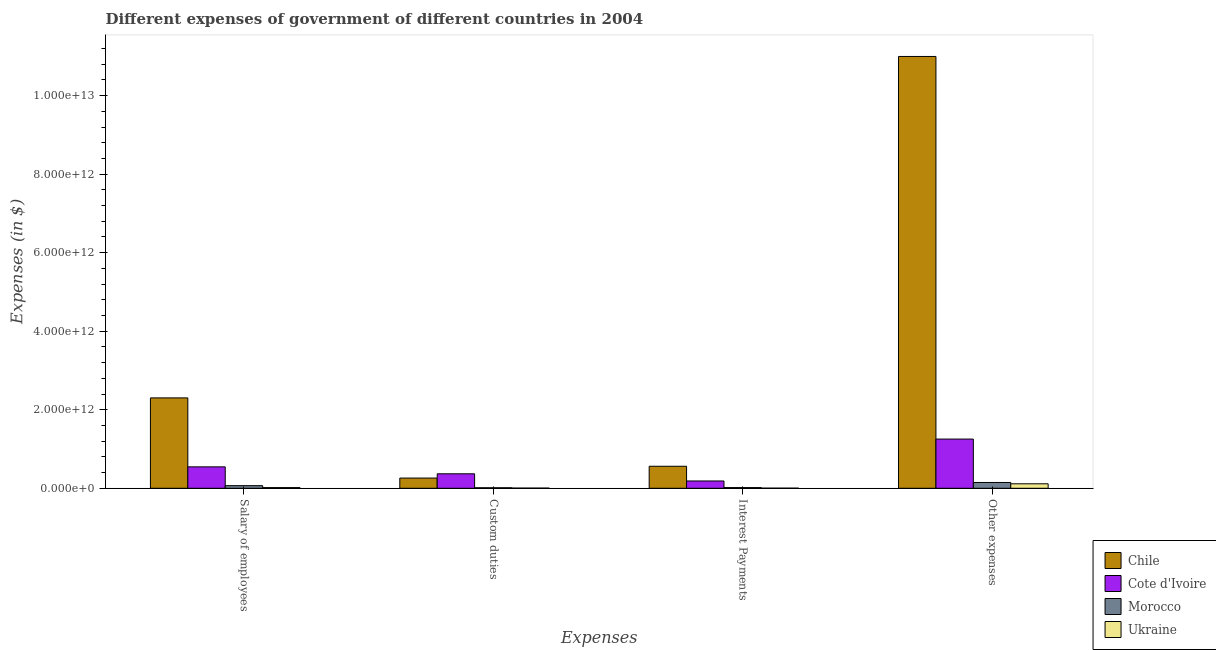How many different coloured bars are there?
Your answer should be compact. 4. Are the number of bars per tick equal to the number of legend labels?
Ensure brevity in your answer.  Yes. How many bars are there on the 2nd tick from the left?
Offer a terse response. 4. How many bars are there on the 4th tick from the right?
Your answer should be very brief. 4. What is the label of the 3rd group of bars from the left?
Provide a short and direct response. Interest Payments. What is the amount spent on interest payments in Chile?
Provide a short and direct response. 5.61e+11. Across all countries, what is the maximum amount spent on other expenses?
Give a very brief answer. 1.10e+13. Across all countries, what is the minimum amount spent on custom duties?
Your response must be concise. 4.37e+09. In which country was the amount spent on interest payments maximum?
Make the answer very short. Chile. In which country was the amount spent on salary of employees minimum?
Your answer should be very brief. Ukraine. What is the total amount spent on custom duties in the graph?
Your answer should be compact. 6.46e+11. What is the difference between the amount spent on other expenses in Chile and that in Ukraine?
Provide a succinct answer. 1.09e+13. What is the difference between the amount spent on other expenses in Chile and the amount spent on custom duties in Cote d'Ivoire?
Ensure brevity in your answer.  1.06e+13. What is the average amount spent on salary of employees per country?
Offer a terse response. 7.33e+11. What is the difference between the amount spent on salary of employees and amount spent on custom duties in Cote d'Ivoire?
Provide a short and direct response. 1.77e+11. In how many countries, is the amount spent on custom duties greater than 4000000000000 $?
Offer a very short reply. 0. What is the ratio of the amount spent on interest payments in Morocco to that in Cote d'Ivoire?
Ensure brevity in your answer.  0.1. Is the amount spent on custom duties in Ukraine less than that in Chile?
Your answer should be compact. Yes. Is the difference between the amount spent on custom duties in Ukraine and Morocco greater than the difference between the amount spent on salary of employees in Ukraine and Morocco?
Ensure brevity in your answer.  Yes. What is the difference between the highest and the second highest amount spent on custom duties?
Provide a short and direct response. 1.09e+11. What is the difference between the highest and the lowest amount spent on salary of employees?
Your answer should be compact. 2.28e+12. What does the 3rd bar from the left in Interest Payments represents?
Your answer should be very brief. Morocco. Is it the case that in every country, the sum of the amount spent on salary of employees and amount spent on custom duties is greater than the amount spent on interest payments?
Offer a terse response. Yes. Are all the bars in the graph horizontal?
Provide a short and direct response. No. How many countries are there in the graph?
Provide a short and direct response. 4. What is the difference between two consecutive major ticks on the Y-axis?
Provide a succinct answer. 2.00e+12. Are the values on the major ticks of Y-axis written in scientific E-notation?
Offer a terse response. Yes. Does the graph contain any zero values?
Make the answer very short. No. Does the graph contain grids?
Offer a very short reply. No. Where does the legend appear in the graph?
Keep it short and to the point. Bottom right. What is the title of the graph?
Your answer should be very brief. Different expenses of government of different countries in 2004. What is the label or title of the X-axis?
Ensure brevity in your answer.  Expenses. What is the label or title of the Y-axis?
Your response must be concise. Expenses (in $). What is the Expenses (in $) in Chile in Salary of employees?
Make the answer very short. 2.30e+12. What is the Expenses (in $) of Cote d'Ivoire in Salary of employees?
Provide a short and direct response. 5.46e+11. What is the Expenses (in $) in Morocco in Salary of employees?
Your answer should be compact. 6.65e+1. What is the Expenses (in $) in Ukraine in Salary of employees?
Provide a succinct answer. 1.79e+1. What is the Expenses (in $) in Chile in Custom duties?
Offer a terse response. 2.60e+11. What is the Expenses (in $) in Cote d'Ivoire in Custom duties?
Your response must be concise. 3.69e+11. What is the Expenses (in $) of Morocco in Custom duties?
Your response must be concise. 1.33e+1. What is the Expenses (in $) of Ukraine in Custom duties?
Your answer should be compact. 4.37e+09. What is the Expenses (in $) in Chile in Interest Payments?
Make the answer very short. 5.61e+11. What is the Expenses (in $) in Cote d'Ivoire in Interest Payments?
Provide a short and direct response. 1.86e+11. What is the Expenses (in $) of Morocco in Interest Payments?
Make the answer very short. 1.77e+1. What is the Expenses (in $) in Ukraine in Interest Payments?
Ensure brevity in your answer.  3.05e+09. What is the Expenses (in $) of Chile in Other expenses?
Your response must be concise. 1.10e+13. What is the Expenses (in $) in Cote d'Ivoire in Other expenses?
Offer a very short reply. 1.25e+12. What is the Expenses (in $) of Morocco in Other expenses?
Offer a very short reply. 1.48e+11. What is the Expenses (in $) in Ukraine in Other expenses?
Provide a succinct answer. 1.14e+11. Across all Expenses, what is the maximum Expenses (in $) in Chile?
Ensure brevity in your answer.  1.10e+13. Across all Expenses, what is the maximum Expenses (in $) in Cote d'Ivoire?
Your answer should be compact. 1.25e+12. Across all Expenses, what is the maximum Expenses (in $) of Morocco?
Provide a succinct answer. 1.48e+11. Across all Expenses, what is the maximum Expenses (in $) of Ukraine?
Keep it short and to the point. 1.14e+11. Across all Expenses, what is the minimum Expenses (in $) of Chile?
Keep it short and to the point. 2.60e+11. Across all Expenses, what is the minimum Expenses (in $) of Cote d'Ivoire?
Make the answer very short. 1.86e+11. Across all Expenses, what is the minimum Expenses (in $) of Morocco?
Provide a succinct answer. 1.33e+1. Across all Expenses, what is the minimum Expenses (in $) of Ukraine?
Ensure brevity in your answer.  3.05e+09. What is the total Expenses (in $) in Chile in the graph?
Provide a short and direct response. 1.41e+13. What is the total Expenses (in $) in Cote d'Ivoire in the graph?
Provide a short and direct response. 2.35e+12. What is the total Expenses (in $) in Morocco in the graph?
Provide a short and direct response. 2.45e+11. What is the total Expenses (in $) in Ukraine in the graph?
Provide a succinct answer. 1.39e+11. What is the difference between the Expenses (in $) of Chile in Salary of employees and that in Custom duties?
Keep it short and to the point. 2.04e+12. What is the difference between the Expenses (in $) in Cote d'Ivoire in Salary of employees and that in Custom duties?
Your answer should be very brief. 1.77e+11. What is the difference between the Expenses (in $) in Morocco in Salary of employees and that in Custom duties?
Your answer should be compact. 5.32e+1. What is the difference between the Expenses (in $) of Ukraine in Salary of employees and that in Custom duties?
Give a very brief answer. 1.35e+1. What is the difference between the Expenses (in $) of Chile in Salary of employees and that in Interest Payments?
Offer a very short reply. 1.74e+12. What is the difference between the Expenses (in $) of Cote d'Ivoire in Salary of employees and that in Interest Payments?
Offer a very short reply. 3.60e+11. What is the difference between the Expenses (in $) of Morocco in Salary of employees and that in Interest Payments?
Your answer should be very brief. 4.88e+1. What is the difference between the Expenses (in $) of Ukraine in Salary of employees and that in Interest Payments?
Your answer should be very brief. 1.48e+1. What is the difference between the Expenses (in $) of Chile in Salary of employees and that in Other expenses?
Offer a very short reply. -8.69e+12. What is the difference between the Expenses (in $) in Cote d'Ivoire in Salary of employees and that in Other expenses?
Make the answer very short. -7.07e+11. What is the difference between the Expenses (in $) in Morocco in Salary of employees and that in Other expenses?
Provide a short and direct response. -8.11e+1. What is the difference between the Expenses (in $) in Ukraine in Salary of employees and that in Other expenses?
Provide a succinct answer. -9.60e+1. What is the difference between the Expenses (in $) of Chile in Custom duties and that in Interest Payments?
Provide a succinct answer. -3.01e+11. What is the difference between the Expenses (in $) of Cote d'Ivoire in Custom duties and that in Interest Payments?
Make the answer very short. 1.83e+11. What is the difference between the Expenses (in $) of Morocco in Custom duties and that in Interest Payments?
Give a very brief answer. -4.45e+09. What is the difference between the Expenses (in $) of Ukraine in Custom duties and that in Interest Payments?
Your answer should be very brief. 1.32e+09. What is the difference between the Expenses (in $) of Chile in Custom duties and that in Other expenses?
Provide a succinct answer. -1.07e+13. What is the difference between the Expenses (in $) in Cote d'Ivoire in Custom duties and that in Other expenses?
Make the answer very short. -8.84e+11. What is the difference between the Expenses (in $) of Morocco in Custom duties and that in Other expenses?
Make the answer very short. -1.34e+11. What is the difference between the Expenses (in $) of Ukraine in Custom duties and that in Other expenses?
Offer a terse response. -1.09e+11. What is the difference between the Expenses (in $) in Chile in Interest Payments and that in Other expenses?
Keep it short and to the point. -1.04e+13. What is the difference between the Expenses (in $) in Cote d'Ivoire in Interest Payments and that in Other expenses?
Provide a succinct answer. -1.07e+12. What is the difference between the Expenses (in $) of Morocco in Interest Payments and that in Other expenses?
Ensure brevity in your answer.  -1.30e+11. What is the difference between the Expenses (in $) of Ukraine in Interest Payments and that in Other expenses?
Ensure brevity in your answer.  -1.11e+11. What is the difference between the Expenses (in $) of Chile in Salary of employees and the Expenses (in $) of Cote d'Ivoire in Custom duties?
Ensure brevity in your answer.  1.93e+12. What is the difference between the Expenses (in $) of Chile in Salary of employees and the Expenses (in $) of Morocco in Custom duties?
Ensure brevity in your answer.  2.29e+12. What is the difference between the Expenses (in $) of Chile in Salary of employees and the Expenses (in $) of Ukraine in Custom duties?
Keep it short and to the point. 2.30e+12. What is the difference between the Expenses (in $) of Cote d'Ivoire in Salary of employees and the Expenses (in $) of Morocco in Custom duties?
Keep it short and to the point. 5.33e+11. What is the difference between the Expenses (in $) in Cote d'Ivoire in Salary of employees and the Expenses (in $) in Ukraine in Custom duties?
Your answer should be very brief. 5.41e+11. What is the difference between the Expenses (in $) of Morocco in Salary of employees and the Expenses (in $) of Ukraine in Custom duties?
Give a very brief answer. 6.22e+1. What is the difference between the Expenses (in $) in Chile in Salary of employees and the Expenses (in $) in Cote d'Ivoire in Interest Payments?
Provide a succinct answer. 2.12e+12. What is the difference between the Expenses (in $) in Chile in Salary of employees and the Expenses (in $) in Morocco in Interest Payments?
Give a very brief answer. 2.28e+12. What is the difference between the Expenses (in $) of Chile in Salary of employees and the Expenses (in $) of Ukraine in Interest Payments?
Offer a very short reply. 2.30e+12. What is the difference between the Expenses (in $) in Cote d'Ivoire in Salary of employees and the Expenses (in $) in Morocco in Interest Payments?
Ensure brevity in your answer.  5.28e+11. What is the difference between the Expenses (in $) in Cote d'Ivoire in Salary of employees and the Expenses (in $) in Ukraine in Interest Payments?
Make the answer very short. 5.43e+11. What is the difference between the Expenses (in $) of Morocco in Salary of employees and the Expenses (in $) of Ukraine in Interest Payments?
Your answer should be very brief. 6.35e+1. What is the difference between the Expenses (in $) in Chile in Salary of employees and the Expenses (in $) in Cote d'Ivoire in Other expenses?
Make the answer very short. 1.05e+12. What is the difference between the Expenses (in $) in Chile in Salary of employees and the Expenses (in $) in Morocco in Other expenses?
Offer a very short reply. 2.15e+12. What is the difference between the Expenses (in $) of Chile in Salary of employees and the Expenses (in $) of Ukraine in Other expenses?
Your answer should be very brief. 2.19e+12. What is the difference between the Expenses (in $) in Cote d'Ivoire in Salary of employees and the Expenses (in $) in Morocco in Other expenses?
Ensure brevity in your answer.  3.98e+11. What is the difference between the Expenses (in $) of Cote d'Ivoire in Salary of employees and the Expenses (in $) of Ukraine in Other expenses?
Your answer should be very brief. 4.32e+11. What is the difference between the Expenses (in $) in Morocco in Salary of employees and the Expenses (in $) in Ukraine in Other expenses?
Provide a short and direct response. -4.73e+1. What is the difference between the Expenses (in $) of Chile in Custom duties and the Expenses (in $) of Cote d'Ivoire in Interest Payments?
Ensure brevity in your answer.  7.38e+1. What is the difference between the Expenses (in $) in Chile in Custom duties and the Expenses (in $) in Morocco in Interest Payments?
Provide a succinct answer. 2.42e+11. What is the difference between the Expenses (in $) in Chile in Custom duties and the Expenses (in $) in Ukraine in Interest Payments?
Provide a succinct answer. 2.57e+11. What is the difference between the Expenses (in $) in Cote d'Ivoire in Custom duties and the Expenses (in $) in Morocco in Interest Payments?
Keep it short and to the point. 3.51e+11. What is the difference between the Expenses (in $) of Cote d'Ivoire in Custom duties and the Expenses (in $) of Ukraine in Interest Payments?
Your answer should be compact. 3.66e+11. What is the difference between the Expenses (in $) in Morocco in Custom duties and the Expenses (in $) in Ukraine in Interest Payments?
Offer a very short reply. 1.02e+1. What is the difference between the Expenses (in $) of Chile in Custom duties and the Expenses (in $) of Cote d'Ivoire in Other expenses?
Offer a very short reply. -9.93e+11. What is the difference between the Expenses (in $) of Chile in Custom duties and the Expenses (in $) of Morocco in Other expenses?
Your answer should be very brief. 1.12e+11. What is the difference between the Expenses (in $) of Chile in Custom duties and the Expenses (in $) of Ukraine in Other expenses?
Offer a terse response. 1.46e+11. What is the difference between the Expenses (in $) in Cote d'Ivoire in Custom duties and the Expenses (in $) in Morocco in Other expenses?
Your answer should be very brief. 2.21e+11. What is the difference between the Expenses (in $) of Cote d'Ivoire in Custom duties and the Expenses (in $) of Ukraine in Other expenses?
Give a very brief answer. 2.55e+11. What is the difference between the Expenses (in $) of Morocco in Custom duties and the Expenses (in $) of Ukraine in Other expenses?
Make the answer very short. -1.01e+11. What is the difference between the Expenses (in $) in Chile in Interest Payments and the Expenses (in $) in Cote d'Ivoire in Other expenses?
Keep it short and to the point. -6.92e+11. What is the difference between the Expenses (in $) of Chile in Interest Payments and the Expenses (in $) of Morocco in Other expenses?
Offer a terse response. 4.13e+11. What is the difference between the Expenses (in $) of Chile in Interest Payments and the Expenses (in $) of Ukraine in Other expenses?
Provide a succinct answer. 4.47e+11. What is the difference between the Expenses (in $) of Cote d'Ivoire in Interest Payments and the Expenses (in $) of Morocco in Other expenses?
Provide a succinct answer. 3.84e+1. What is the difference between the Expenses (in $) in Cote d'Ivoire in Interest Payments and the Expenses (in $) in Ukraine in Other expenses?
Your response must be concise. 7.23e+1. What is the difference between the Expenses (in $) of Morocco in Interest Payments and the Expenses (in $) of Ukraine in Other expenses?
Offer a very short reply. -9.61e+1. What is the average Expenses (in $) of Chile per Expenses?
Give a very brief answer. 3.53e+12. What is the average Expenses (in $) of Cote d'Ivoire per Expenses?
Your answer should be compact. 5.88e+11. What is the average Expenses (in $) in Morocco per Expenses?
Give a very brief answer. 6.13e+1. What is the average Expenses (in $) in Ukraine per Expenses?
Your answer should be very brief. 3.48e+1. What is the difference between the Expenses (in $) of Chile and Expenses (in $) of Cote d'Ivoire in Salary of employees?
Your response must be concise. 1.76e+12. What is the difference between the Expenses (in $) in Chile and Expenses (in $) in Morocco in Salary of employees?
Provide a succinct answer. 2.24e+12. What is the difference between the Expenses (in $) in Chile and Expenses (in $) in Ukraine in Salary of employees?
Provide a short and direct response. 2.28e+12. What is the difference between the Expenses (in $) in Cote d'Ivoire and Expenses (in $) in Morocco in Salary of employees?
Your answer should be very brief. 4.79e+11. What is the difference between the Expenses (in $) of Cote d'Ivoire and Expenses (in $) of Ukraine in Salary of employees?
Give a very brief answer. 5.28e+11. What is the difference between the Expenses (in $) of Morocco and Expenses (in $) of Ukraine in Salary of employees?
Ensure brevity in your answer.  4.87e+1. What is the difference between the Expenses (in $) in Chile and Expenses (in $) in Cote d'Ivoire in Custom duties?
Your response must be concise. -1.09e+11. What is the difference between the Expenses (in $) in Chile and Expenses (in $) in Morocco in Custom duties?
Give a very brief answer. 2.47e+11. What is the difference between the Expenses (in $) of Chile and Expenses (in $) of Ukraine in Custom duties?
Provide a short and direct response. 2.56e+11. What is the difference between the Expenses (in $) in Cote d'Ivoire and Expenses (in $) in Morocco in Custom duties?
Offer a terse response. 3.55e+11. What is the difference between the Expenses (in $) of Cote d'Ivoire and Expenses (in $) of Ukraine in Custom duties?
Provide a succinct answer. 3.64e+11. What is the difference between the Expenses (in $) in Morocco and Expenses (in $) in Ukraine in Custom duties?
Provide a succinct answer. 8.92e+09. What is the difference between the Expenses (in $) of Chile and Expenses (in $) of Cote d'Ivoire in Interest Payments?
Offer a terse response. 3.75e+11. What is the difference between the Expenses (in $) of Chile and Expenses (in $) of Morocco in Interest Payments?
Make the answer very short. 5.43e+11. What is the difference between the Expenses (in $) of Chile and Expenses (in $) of Ukraine in Interest Payments?
Make the answer very short. 5.58e+11. What is the difference between the Expenses (in $) in Cote d'Ivoire and Expenses (in $) in Morocco in Interest Payments?
Ensure brevity in your answer.  1.68e+11. What is the difference between the Expenses (in $) of Cote d'Ivoire and Expenses (in $) of Ukraine in Interest Payments?
Offer a very short reply. 1.83e+11. What is the difference between the Expenses (in $) of Morocco and Expenses (in $) of Ukraine in Interest Payments?
Ensure brevity in your answer.  1.47e+1. What is the difference between the Expenses (in $) of Chile and Expenses (in $) of Cote d'Ivoire in Other expenses?
Your response must be concise. 9.74e+12. What is the difference between the Expenses (in $) of Chile and Expenses (in $) of Morocco in Other expenses?
Your response must be concise. 1.08e+13. What is the difference between the Expenses (in $) in Chile and Expenses (in $) in Ukraine in Other expenses?
Give a very brief answer. 1.09e+13. What is the difference between the Expenses (in $) in Cote d'Ivoire and Expenses (in $) in Morocco in Other expenses?
Your answer should be very brief. 1.11e+12. What is the difference between the Expenses (in $) of Cote d'Ivoire and Expenses (in $) of Ukraine in Other expenses?
Provide a succinct answer. 1.14e+12. What is the difference between the Expenses (in $) in Morocco and Expenses (in $) in Ukraine in Other expenses?
Your answer should be compact. 3.38e+1. What is the ratio of the Expenses (in $) in Chile in Salary of employees to that in Custom duties?
Provide a short and direct response. 8.85. What is the ratio of the Expenses (in $) in Cote d'Ivoire in Salary of employees to that in Custom duties?
Provide a succinct answer. 1.48. What is the ratio of the Expenses (in $) of Morocco in Salary of employees to that in Custom duties?
Your response must be concise. 5.01. What is the ratio of the Expenses (in $) in Ukraine in Salary of employees to that in Custom duties?
Give a very brief answer. 4.09. What is the ratio of the Expenses (in $) of Chile in Salary of employees to that in Interest Payments?
Provide a short and direct response. 4.1. What is the ratio of the Expenses (in $) of Cote d'Ivoire in Salary of employees to that in Interest Payments?
Offer a terse response. 2.93. What is the ratio of the Expenses (in $) in Morocco in Salary of employees to that in Interest Payments?
Ensure brevity in your answer.  3.75. What is the ratio of the Expenses (in $) of Ukraine in Salary of employees to that in Interest Payments?
Provide a short and direct response. 5.86. What is the ratio of the Expenses (in $) in Chile in Salary of employees to that in Other expenses?
Your answer should be very brief. 0.21. What is the ratio of the Expenses (in $) in Cote d'Ivoire in Salary of employees to that in Other expenses?
Offer a very short reply. 0.44. What is the ratio of the Expenses (in $) in Morocco in Salary of employees to that in Other expenses?
Your answer should be compact. 0.45. What is the ratio of the Expenses (in $) of Ukraine in Salary of employees to that in Other expenses?
Offer a very short reply. 0.16. What is the ratio of the Expenses (in $) in Chile in Custom duties to that in Interest Payments?
Your response must be concise. 0.46. What is the ratio of the Expenses (in $) of Cote d'Ivoire in Custom duties to that in Interest Payments?
Your answer should be compact. 1.98. What is the ratio of the Expenses (in $) in Morocco in Custom duties to that in Interest Payments?
Give a very brief answer. 0.75. What is the ratio of the Expenses (in $) in Ukraine in Custom duties to that in Interest Payments?
Give a very brief answer. 1.43. What is the ratio of the Expenses (in $) in Chile in Custom duties to that in Other expenses?
Provide a succinct answer. 0.02. What is the ratio of the Expenses (in $) in Cote d'Ivoire in Custom duties to that in Other expenses?
Provide a succinct answer. 0.29. What is the ratio of the Expenses (in $) of Morocco in Custom duties to that in Other expenses?
Provide a short and direct response. 0.09. What is the ratio of the Expenses (in $) of Ukraine in Custom duties to that in Other expenses?
Ensure brevity in your answer.  0.04. What is the ratio of the Expenses (in $) of Chile in Interest Payments to that in Other expenses?
Ensure brevity in your answer.  0.05. What is the ratio of the Expenses (in $) of Cote d'Ivoire in Interest Payments to that in Other expenses?
Provide a succinct answer. 0.15. What is the ratio of the Expenses (in $) of Morocco in Interest Payments to that in Other expenses?
Make the answer very short. 0.12. What is the ratio of the Expenses (in $) in Ukraine in Interest Payments to that in Other expenses?
Ensure brevity in your answer.  0.03. What is the difference between the highest and the second highest Expenses (in $) of Chile?
Provide a short and direct response. 8.69e+12. What is the difference between the highest and the second highest Expenses (in $) of Cote d'Ivoire?
Provide a succinct answer. 7.07e+11. What is the difference between the highest and the second highest Expenses (in $) of Morocco?
Provide a short and direct response. 8.11e+1. What is the difference between the highest and the second highest Expenses (in $) of Ukraine?
Make the answer very short. 9.60e+1. What is the difference between the highest and the lowest Expenses (in $) of Chile?
Keep it short and to the point. 1.07e+13. What is the difference between the highest and the lowest Expenses (in $) in Cote d'Ivoire?
Offer a very short reply. 1.07e+12. What is the difference between the highest and the lowest Expenses (in $) in Morocco?
Give a very brief answer. 1.34e+11. What is the difference between the highest and the lowest Expenses (in $) of Ukraine?
Provide a short and direct response. 1.11e+11. 